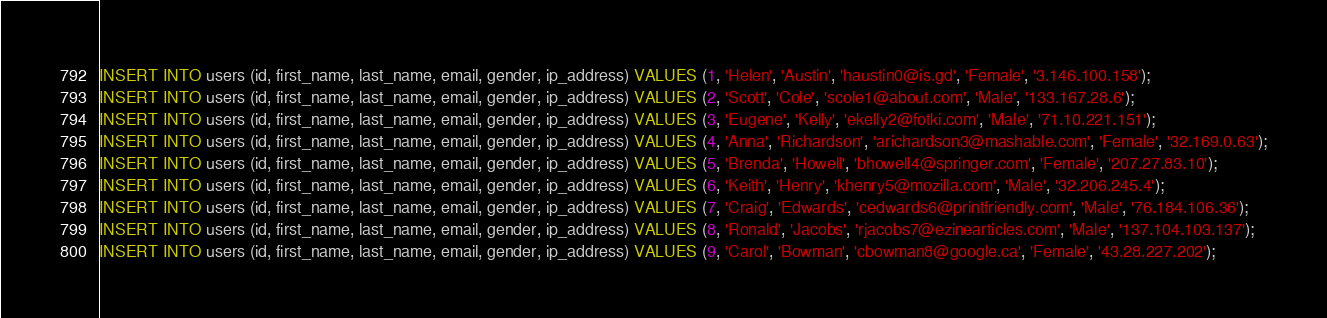Convert code to text. <code><loc_0><loc_0><loc_500><loc_500><_SQL_>INSERT INTO users (id, first_name, last_name, email, gender, ip_address) VALUES (1, 'Helen', 'Austin', 'haustin0@is.gd', 'Female', '3.146.100.158');
INSERT INTO users (id, first_name, last_name, email, gender, ip_address) VALUES (2, 'Scott', 'Cole', 'scole1@about.com', 'Male', '133.167.28.6');
INSERT INTO users (id, first_name, last_name, email, gender, ip_address) VALUES (3, 'Eugene', 'Kelly', 'ekelly2@fotki.com', 'Male', '71.10.221.151');
INSERT INTO users (id, first_name, last_name, email, gender, ip_address) VALUES (4, 'Anna', 'Richardson', 'arichardson3@mashable.com', 'Female', '32.169.0.63');
INSERT INTO users (id, first_name, last_name, email, gender, ip_address) VALUES (5, 'Brenda', 'Howell', 'bhowell4@springer.com', 'Female', '207.27.83.10');
INSERT INTO users (id, first_name, last_name, email, gender, ip_address) VALUES (6, 'Keith', 'Henry', 'khenry5@mozilla.com', 'Male', '32.206.245.4');
INSERT INTO users (id, first_name, last_name, email, gender, ip_address) VALUES (7, 'Craig', 'Edwards', 'cedwards6@printfriendly.com', 'Male', '76.184.106.36');
INSERT INTO users (id, first_name, last_name, email, gender, ip_address) VALUES (8, 'Ronald', 'Jacobs', 'rjacobs7@ezinearticles.com', 'Male', '137.104.103.137');
INSERT INTO users (id, first_name, last_name, email, gender, ip_address) VALUES (9, 'Carol', 'Bowman', 'cbowman8@google.ca', 'Female', '43.28.227.202');</code> 